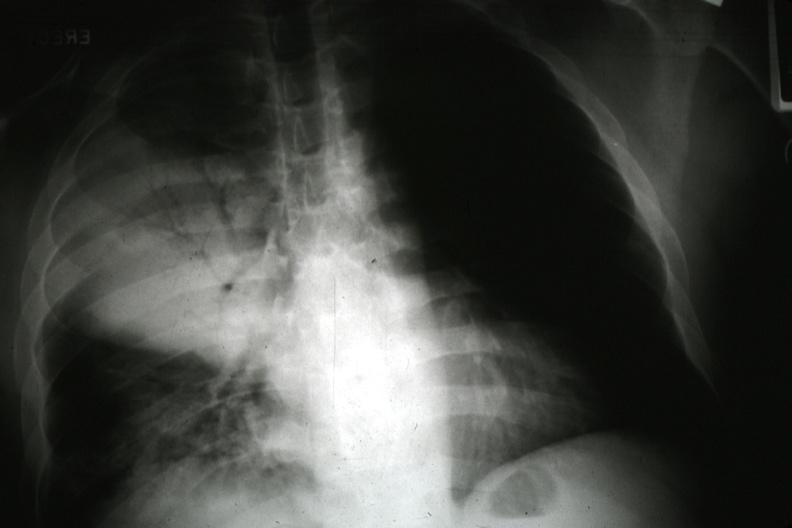where is this?
Answer the question using a single word or phrase. Lung 